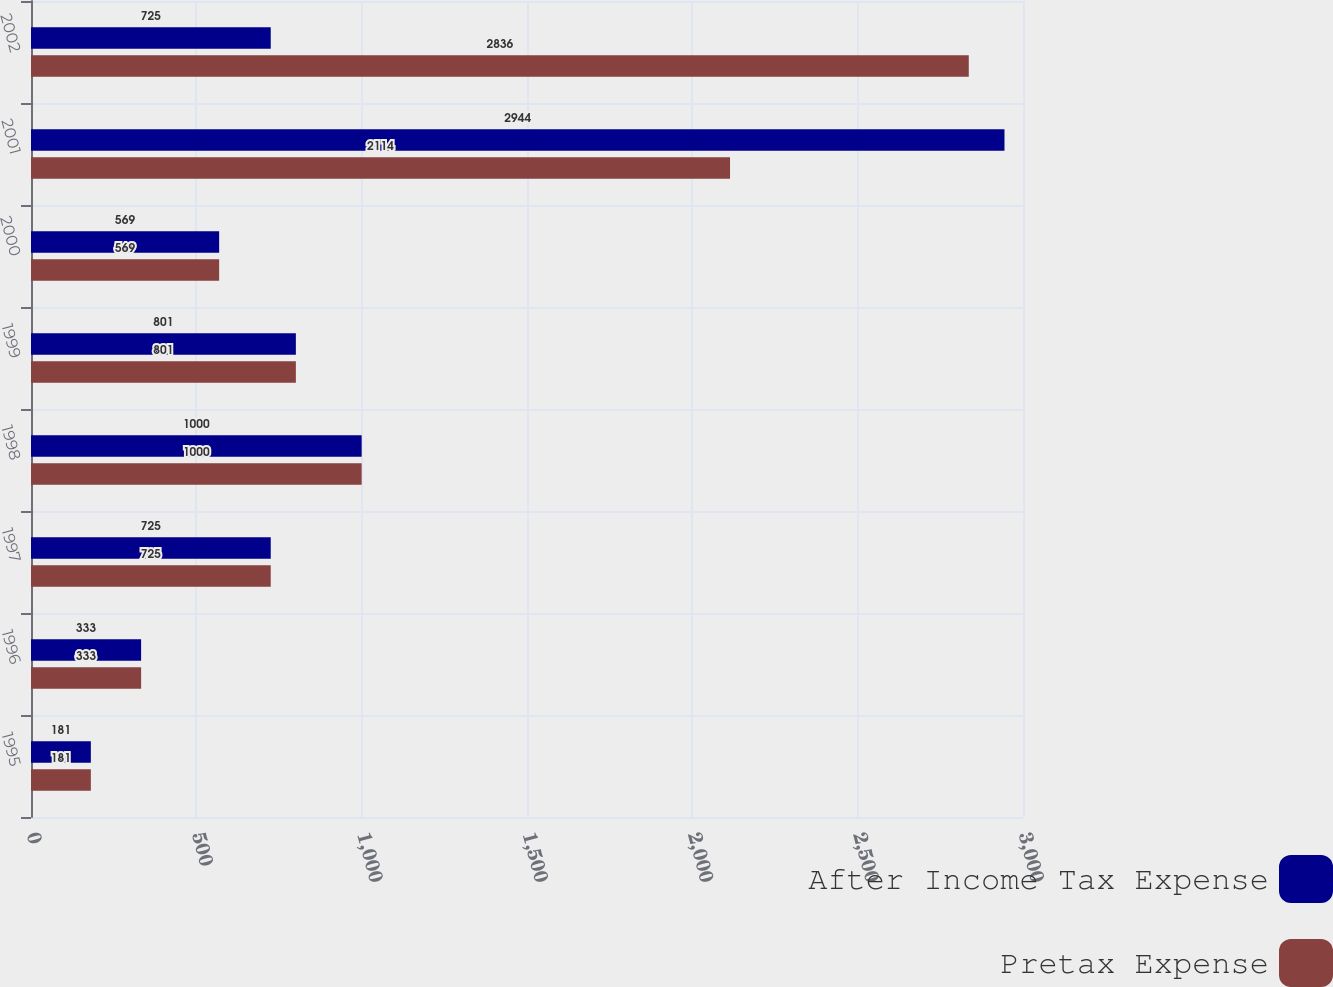Convert chart. <chart><loc_0><loc_0><loc_500><loc_500><stacked_bar_chart><ecel><fcel>1995<fcel>1996<fcel>1997<fcel>1998<fcel>1999<fcel>2000<fcel>2001<fcel>2002<nl><fcel>After Income Tax Expense<fcel>181<fcel>333<fcel>725<fcel>1000<fcel>801<fcel>569<fcel>2944<fcel>725<nl><fcel>Pretax Expense<fcel>181<fcel>333<fcel>725<fcel>1000<fcel>801<fcel>569<fcel>2114<fcel>2836<nl></chart> 